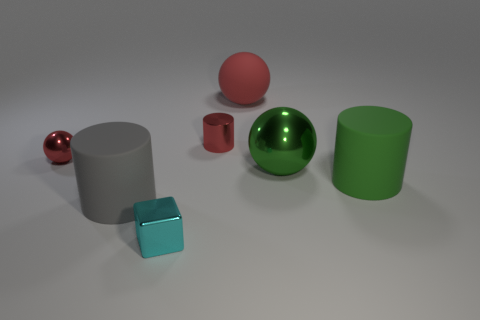Add 1 big gray metallic objects. How many objects exist? 8 Subtract all blocks. How many objects are left? 6 Subtract 1 cyan cubes. How many objects are left? 6 Subtract all red metallic cylinders. Subtract all large objects. How many objects are left? 2 Add 2 big matte cylinders. How many big matte cylinders are left? 4 Add 4 large gray cylinders. How many large gray cylinders exist? 5 